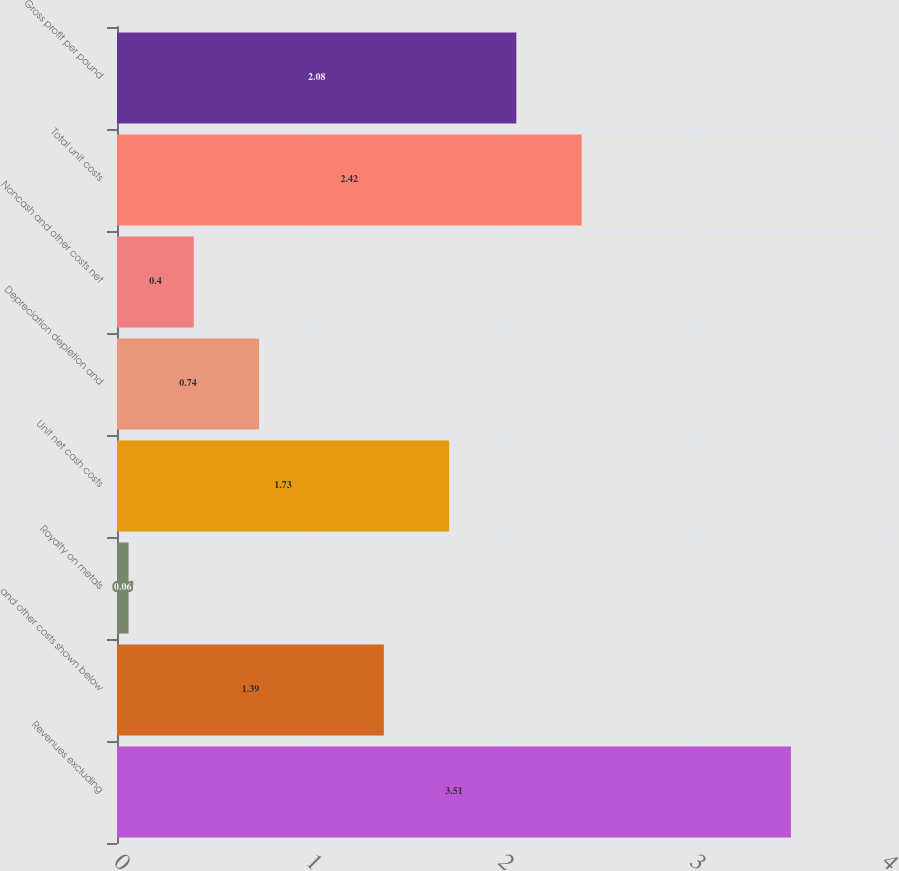Convert chart. <chart><loc_0><loc_0><loc_500><loc_500><bar_chart><fcel>Revenues excluding<fcel>and other costs shown below<fcel>Royalty on metals<fcel>Unit net cash costs<fcel>Depreciation depletion and<fcel>Noncash and other costs net<fcel>Total unit costs<fcel>Gross profit per pound<nl><fcel>3.51<fcel>1.39<fcel>0.06<fcel>1.73<fcel>0.74<fcel>0.4<fcel>2.42<fcel>2.08<nl></chart> 